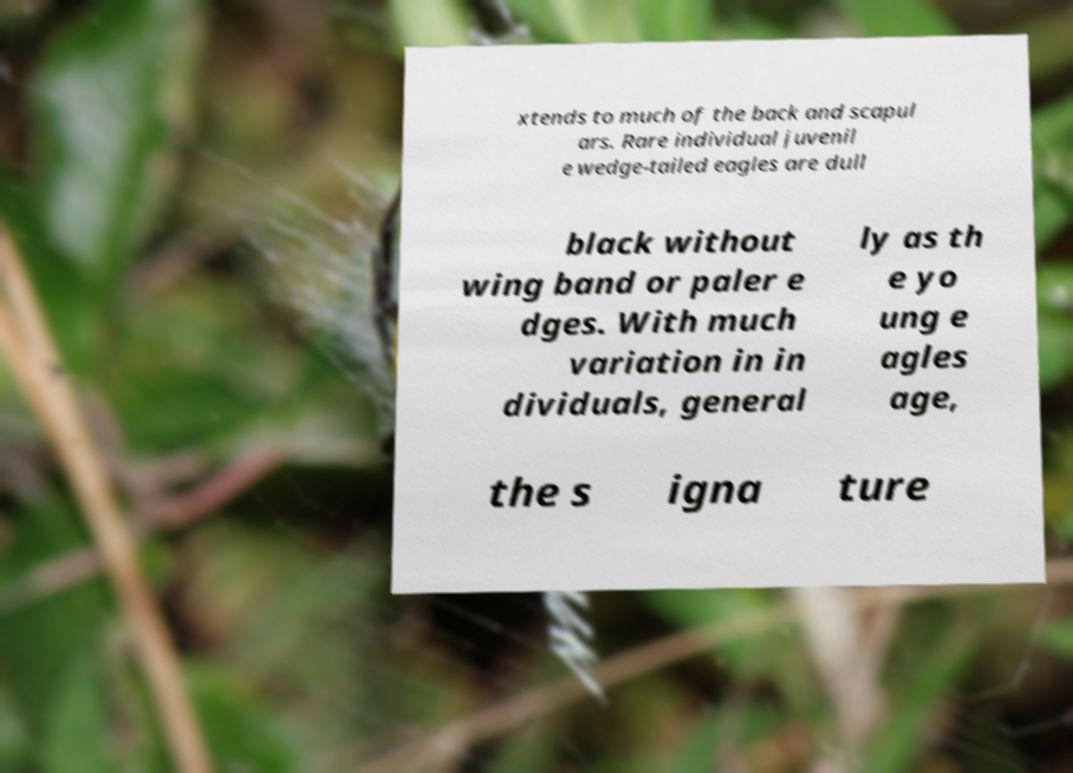Could you assist in decoding the text presented in this image and type it out clearly? xtends to much of the back and scapul ars. Rare individual juvenil e wedge-tailed eagles are dull black without wing band or paler e dges. With much variation in in dividuals, general ly as th e yo ung e agles age, the s igna ture 